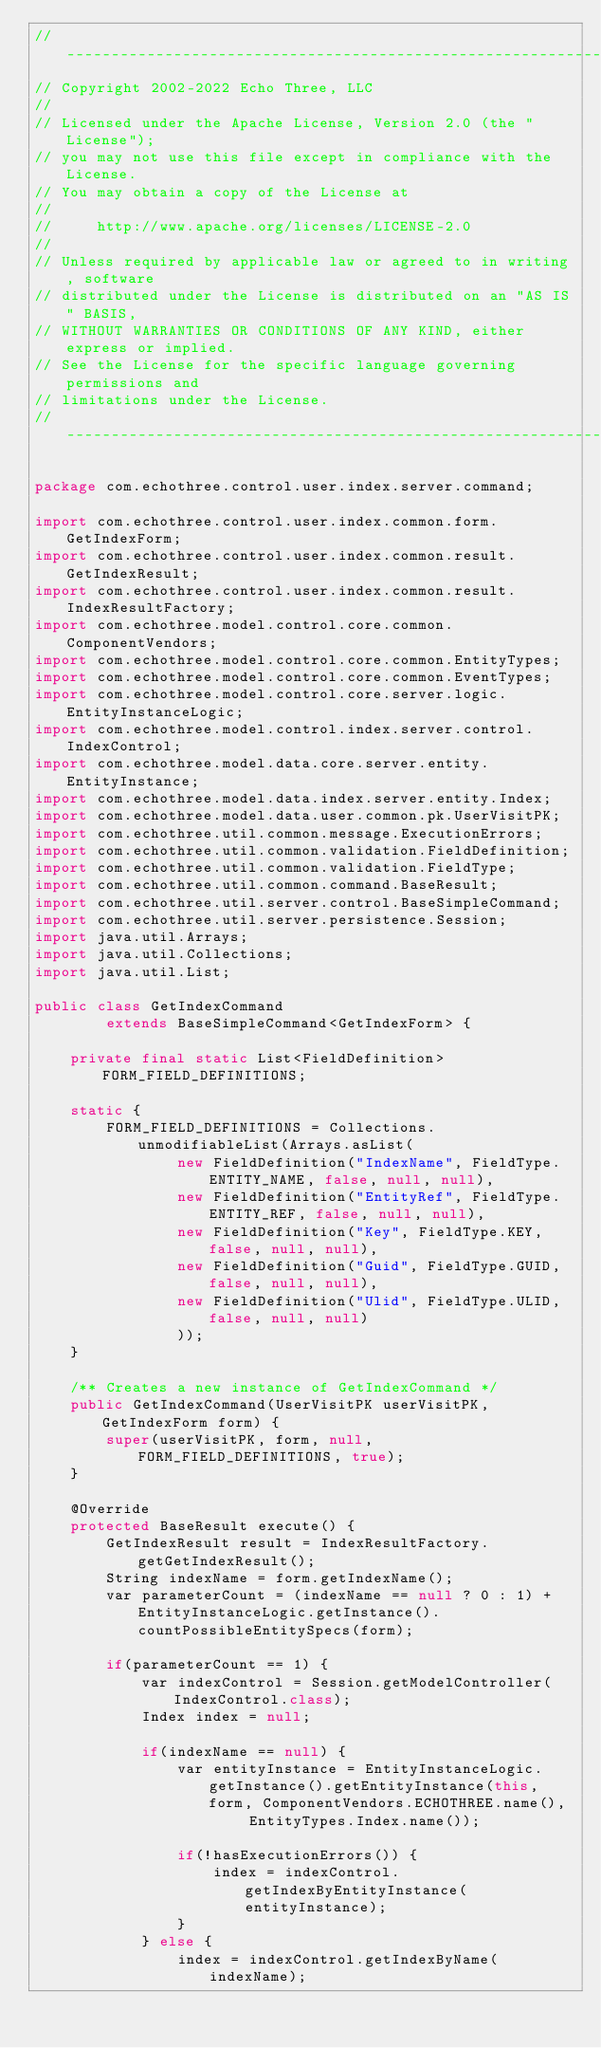<code> <loc_0><loc_0><loc_500><loc_500><_Java_>// --------------------------------------------------------------------------------
// Copyright 2002-2022 Echo Three, LLC
//
// Licensed under the Apache License, Version 2.0 (the "License");
// you may not use this file except in compliance with the License.
// You may obtain a copy of the License at
//
//     http://www.apache.org/licenses/LICENSE-2.0
//
// Unless required by applicable law or agreed to in writing, software
// distributed under the License is distributed on an "AS IS" BASIS,
// WITHOUT WARRANTIES OR CONDITIONS OF ANY KIND, either express or implied.
// See the License for the specific language governing permissions and
// limitations under the License.
// --------------------------------------------------------------------------------

package com.echothree.control.user.index.server.command;

import com.echothree.control.user.index.common.form.GetIndexForm;
import com.echothree.control.user.index.common.result.GetIndexResult;
import com.echothree.control.user.index.common.result.IndexResultFactory;
import com.echothree.model.control.core.common.ComponentVendors;
import com.echothree.model.control.core.common.EntityTypes;
import com.echothree.model.control.core.common.EventTypes;
import com.echothree.model.control.core.server.logic.EntityInstanceLogic;
import com.echothree.model.control.index.server.control.IndexControl;
import com.echothree.model.data.core.server.entity.EntityInstance;
import com.echothree.model.data.index.server.entity.Index;
import com.echothree.model.data.user.common.pk.UserVisitPK;
import com.echothree.util.common.message.ExecutionErrors;
import com.echothree.util.common.validation.FieldDefinition;
import com.echothree.util.common.validation.FieldType;
import com.echothree.util.common.command.BaseResult;
import com.echothree.util.server.control.BaseSimpleCommand;
import com.echothree.util.server.persistence.Session;
import java.util.Arrays;
import java.util.Collections;
import java.util.List;

public class GetIndexCommand
        extends BaseSimpleCommand<GetIndexForm> {
    
    private final static List<FieldDefinition> FORM_FIELD_DEFINITIONS;
    
    static {
        FORM_FIELD_DEFINITIONS = Collections.unmodifiableList(Arrays.asList(
                new FieldDefinition("IndexName", FieldType.ENTITY_NAME, false, null, null),
                new FieldDefinition("EntityRef", FieldType.ENTITY_REF, false, null, null),
                new FieldDefinition("Key", FieldType.KEY, false, null, null),
                new FieldDefinition("Guid", FieldType.GUID, false, null, null),
                new FieldDefinition("Ulid", FieldType.ULID, false, null, null)
                ));
    }
    
    /** Creates a new instance of GetIndexCommand */
    public GetIndexCommand(UserVisitPK userVisitPK, GetIndexForm form) {
        super(userVisitPK, form, null, FORM_FIELD_DEFINITIONS, true);
    }
    
    @Override
    protected BaseResult execute() {
        GetIndexResult result = IndexResultFactory.getGetIndexResult();
        String indexName = form.getIndexName();
        var parameterCount = (indexName == null ? 0 : 1) + EntityInstanceLogic.getInstance().countPossibleEntitySpecs(form);

        if(parameterCount == 1) {
            var indexControl = Session.getModelController(IndexControl.class);
            Index index = null;

            if(indexName == null) {
                var entityInstance = EntityInstanceLogic.getInstance().getEntityInstance(this, form, ComponentVendors.ECHOTHREE.name(),
                        EntityTypes.Index.name());
                
                if(!hasExecutionErrors()) {
                    index = indexControl.getIndexByEntityInstance(entityInstance);
                }
            } else {
                index = indexControl.getIndexByName(indexName);
</code> 